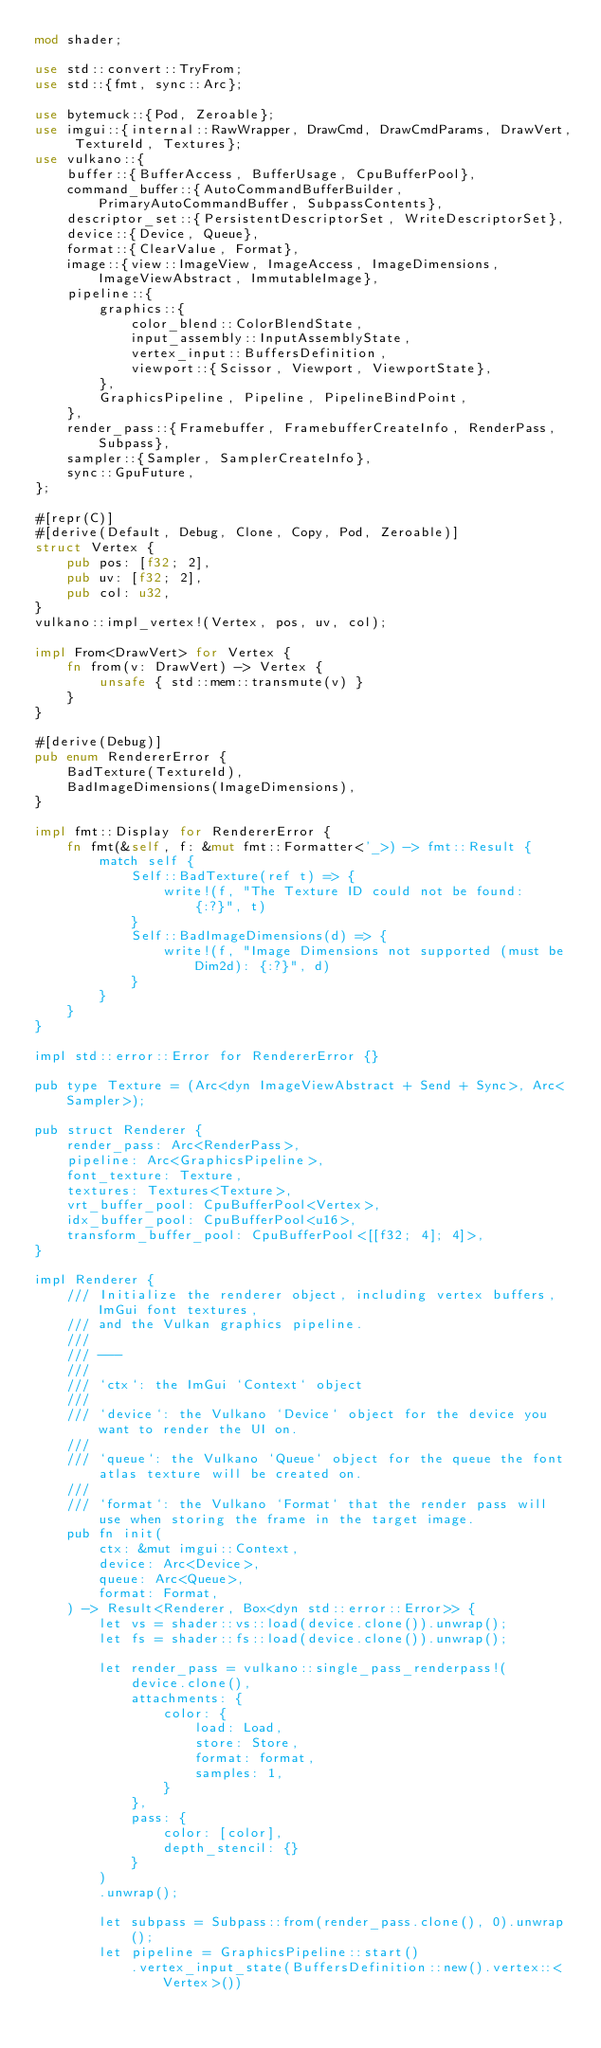Convert code to text. <code><loc_0><loc_0><loc_500><loc_500><_Rust_>mod shader;

use std::convert::TryFrom;
use std::{fmt, sync::Arc};

use bytemuck::{Pod, Zeroable};
use imgui::{internal::RawWrapper, DrawCmd, DrawCmdParams, DrawVert, TextureId, Textures};
use vulkano::{
    buffer::{BufferAccess, BufferUsage, CpuBufferPool},
    command_buffer::{AutoCommandBufferBuilder, PrimaryAutoCommandBuffer, SubpassContents},
    descriptor_set::{PersistentDescriptorSet, WriteDescriptorSet},
    device::{Device, Queue},
    format::{ClearValue, Format},
    image::{view::ImageView, ImageAccess, ImageDimensions, ImageViewAbstract, ImmutableImage},
    pipeline::{
        graphics::{
            color_blend::ColorBlendState,
            input_assembly::InputAssemblyState,
            vertex_input::BuffersDefinition,
            viewport::{Scissor, Viewport, ViewportState},
        },
        GraphicsPipeline, Pipeline, PipelineBindPoint,
    },
    render_pass::{Framebuffer, FramebufferCreateInfo, RenderPass, Subpass},
    sampler::{Sampler, SamplerCreateInfo},
    sync::GpuFuture,
};

#[repr(C)]
#[derive(Default, Debug, Clone, Copy, Pod, Zeroable)]
struct Vertex {
    pub pos: [f32; 2],
    pub uv: [f32; 2],
    pub col: u32,
}
vulkano::impl_vertex!(Vertex, pos, uv, col);

impl From<DrawVert> for Vertex {
    fn from(v: DrawVert) -> Vertex {
        unsafe { std::mem::transmute(v) }
    }
}

#[derive(Debug)]
pub enum RendererError {
    BadTexture(TextureId),
    BadImageDimensions(ImageDimensions),
}

impl fmt::Display for RendererError {
    fn fmt(&self, f: &mut fmt::Formatter<'_>) -> fmt::Result {
        match self {
            Self::BadTexture(ref t) => {
                write!(f, "The Texture ID could not be found: {:?}", t)
            }
            Self::BadImageDimensions(d) => {
                write!(f, "Image Dimensions not supported (must be Dim2d): {:?}", d)
            }
        }
    }
}

impl std::error::Error for RendererError {}

pub type Texture = (Arc<dyn ImageViewAbstract + Send + Sync>, Arc<Sampler>);

pub struct Renderer {
    render_pass: Arc<RenderPass>,
    pipeline: Arc<GraphicsPipeline>,
    font_texture: Texture,
    textures: Textures<Texture>,
    vrt_buffer_pool: CpuBufferPool<Vertex>,
    idx_buffer_pool: CpuBufferPool<u16>,
    transform_buffer_pool: CpuBufferPool<[[f32; 4]; 4]>,
}

impl Renderer {
    /// Initialize the renderer object, including vertex buffers, ImGui font textures,
    /// and the Vulkan graphics pipeline.
    ///
    /// ---
    ///
    /// `ctx`: the ImGui `Context` object
    ///
    /// `device`: the Vulkano `Device` object for the device you want to render the UI on.
    ///
    /// `queue`: the Vulkano `Queue` object for the queue the font atlas texture will be created on.
    ///
    /// `format`: the Vulkano `Format` that the render pass will use when storing the frame in the target image.
    pub fn init(
        ctx: &mut imgui::Context,
        device: Arc<Device>,
        queue: Arc<Queue>,
        format: Format,
    ) -> Result<Renderer, Box<dyn std::error::Error>> {
        let vs = shader::vs::load(device.clone()).unwrap();
        let fs = shader::fs::load(device.clone()).unwrap();

        let render_pass = vulkano::single_pass_renderpass!(
            device.clone(),
            attachments: {
                color: {
                    load: Load,
                    store: Store,
                    format: format,
                    samples: 1,
                }
            },
            pass: {
                color: [color],
                depth_stencil: {}
            }
        )
        .unwrap();

        let subpass = Subpass::from(render_pass.clone(), 0).unwrap();
        let pipeline = GraphicsPipeline::start()
            .vertex_input_state(BuffersDefinition::new().vertex::<Vertex>())</code> 